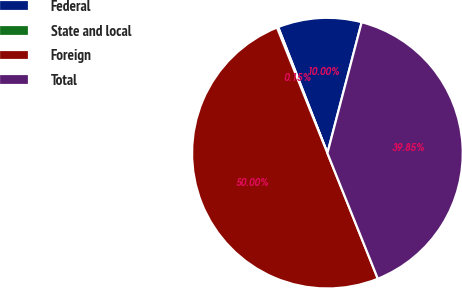Convert chart to OTSL. <chart><loc_0><loc_0><loc_500><loc_500><pie_chart><fcel>Federal<fcel>State and local<fcel>Foreign<fcel>Total<nl><fcel>10.0%<fcel>0.15%<fcel>50.0%<fcel>39.85%<nl></chart> 